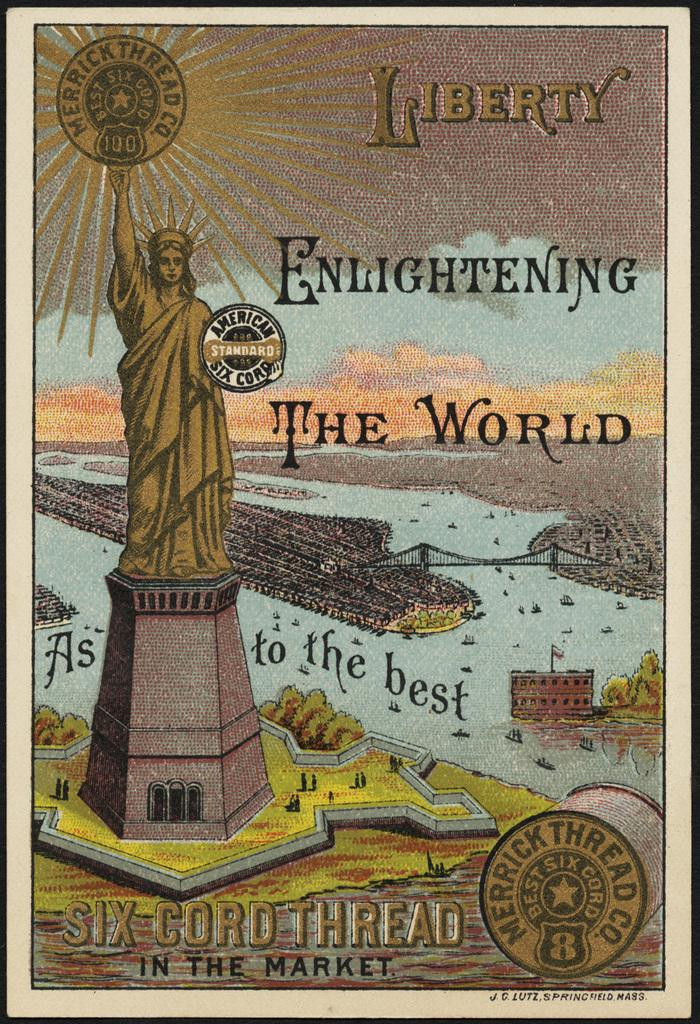<image>
Provide a brief description of the given image. A poster showing the Statue of Liberty by Merrick Thread Co. 